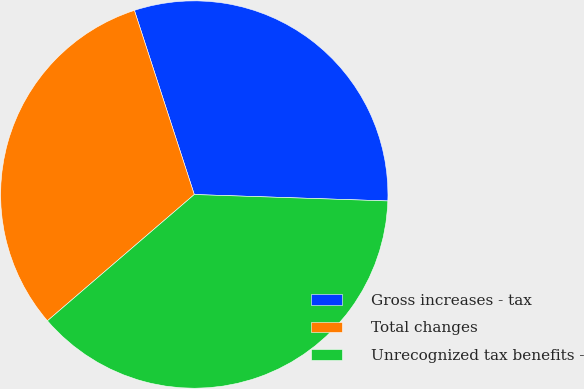Convert chart. <chart><loc_0><loc_0><loc_500><loc_500><pie_chart><fcel>Gross increases - tax<fcel>Total changes<fcel>Unrecognized tax benefits -<nl><fcel>30.53%<fcel>31.3%<fcel>38.17%<nl></chart> 